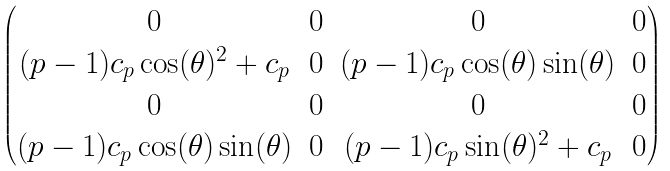Convert formula to latex. <formula><loc_0><loc_0><loc_500><loc_500>\begin{pmatrix} 0 & 0 & 0 & 0 \\ ( p - 1 ) c _ { p } \cos ( \theta ) ^ { 2 } + c _ { p } & 0 & ( p - 1 ) c _ { p } \cos ( \theta ) \sin ( \theta ) & 0 \\ 0 & 0 & 0 & 0 \\ ( p - 1 ) c _ { p } \cos ( \theta ) \sin ( \theta ) & 0 & ( p - 1 ) c _ { p } \sin ( \theta ) ^ { 2 } + c _ { p } & 0 \end{pmatrix}</formula> 